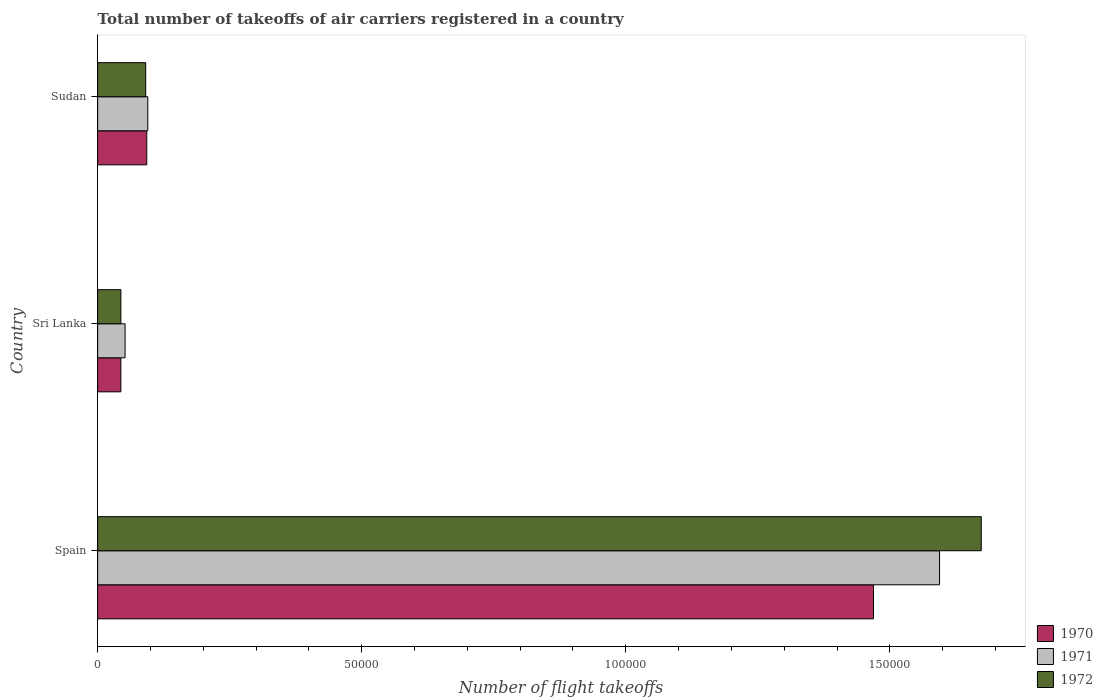How many different coloured bars are there?
Your answer should be very brief. 3. Are the number of bars on each tick of the Y-axis equal?
Give a very brief answer. Yes. How many bars are there on the 1st tick from the top?
Provide a succinct answer. 3. How many bars are there on the 1st tick from the bottom?
Keep it short and to the point. 3. What is the label of the 2nd group of bars from the top?
Offer a terse response. Sri Lanka. What is the total number of flight takeoffs in 1972 in Sudan?
Provide a short and direct response. 9100. Across all countries, what is the maximum total number of flight takeoffs in 1972?
Your response must be concise. 1.67e+05. Across all countries, what is the minimum total number of flight takeoffs in 1972?
Offer a terse response. 4400. In which country was the total number of flight takeoffs in 1971 maximum?
Your answer should be compact. Spain. In which country was the total number of flight takeoffs in 1971 minimum?
Ensure brevity in your answer.  Sri Lanka. What is the total total number of flight takeoffs in 1970 in the graph?
Your answer should be compact. 1.61e+05. What is the difference between the total number of flight takeoffs in 1972 in Sri Lanka and that in Sudan?
Offer a very short reply. -4700. What is the difference between the total number of flight takeoffs in 1971 in Spain and the total number of flight takeoffs in 1972 in Sudan?
Give a very brief answer. 1.50e+05. What is the average total number of flight takeoffs in 1972 per country?
Your answer should be compact. 6.03e+04. What is the difference between the total number of flight takeoffs in 1970 and total number of flight takeoffs in 1972 in Spain?
Provide a short and direct response. -2.04e+04. What is the ratio of the total number of flight takeoffs in 1972 in Sri Lanka to that in Sudan?
Ensure brevity in your answer.  0.48. Is the difference between the total number of flight takeoffs in 1970 in Spain and Sri Lanka greater than the difference between the total number of flight takeoffs in 1972 in Spain and Sri Lanka?
Provide a short and direct response. No. What is the difference between the highest and the second highest total number of flight takeoffs in 1971?
Keep it short and to the point. 1.50e+05. What is the difference between the highest and the lowest total number of flight takeoffs in 1970?
Your answer should be compact. 1.42e+05. In how many countries, is the total number of flight takeoffs in 1972 greater than the average total number of flight takeoffs in 1972 taken over all countries?
Provide a short and direct response. 1. What does the 3rd bar from the bottom in Sri Lanka represents?
Keep it short and to the point. 1972. Is it the case that in every country, the sum of the total number of flight takeoffs in 1971 and total number of flight takeoffs in 1970 is greater than the total number of flight takeoffs in 1972?
Offer a terse response. Yes. How many bars are there?
Offer a terse response. 9. Are all the bars in the graph horizontal?
Provide a succinct answer. Yes. How many countries are there in the graph?
Give a very brief answer. 3. What is the difference between two consecutive major ticks on the X-axis?
Your response must be concise. 5.00e+04. Are the values on the major ticks of X-axis written in scientific E-notation?
Your response must be concise. No. Does the graph contain grids?
Make the answer very short. No. Where does the legend appear in the graph?
Provide a succinct answer. Bottom right. What is the title of the graph?
Offer a terse response. Total number of takeoffs of air carriers registered in a country. Does "1967" appear as one of the legend labels in the graph?
Provide a succinct answer. No. What is the label or title of the X-axis?
Offer a terse response. Number of flight takeoffs. What is the Number of flight takeoffs of 1970 in Spain?
Provide a short and direct response. 1.47e+05. What is the Number of flight takeoffs in 1971 in Spain?
Your answer should be compact. 1.59e+05. What is the Number of flight takeoffs in 1972 in Spain?
Ensure brevity in your answer.  1.67e+05. What is the Number of flight takeoffs of 1970 in Sri Lanka?
Keep it short and to the point. 4400. What is the Number of flight takeoffs of 1971 in Sri Lanka?
Your answer should be compact. 5200. What is the Number of flight takeoffs in 1972 in Sri Lanka?
Keep it short and to the point. 4400. What is the Number of flight takeoffs in 1970 in Sudan?
Offer a very short reply. 9300. What is the Number of flight takeoffs of 1971 in Sudan?
Provide a short and direct response. 9500. What is the Number of flight takeoffs in 1972 in Sudan?
Offer a terse response. 9100. Across all countries, what is the maximum Number of flight takeoffs of 1970?
Provide a succinct answer. 1.47e+05. Across all countries, what is the maximum Number of flight takeoffs of 1971?
Keep it short and to the point. 1.59e+05. Across all countries, what is the maximum Number of flight takeoffs of 1972?
Offer a terse response. 1.67e+05. Across all countries, what is the minimum Number of flight takeoffs in 1970?
Offer a very short reply. 4400. Across all countries, what is the minimum Number of flight takeoffs of 1971?
Provide a succinct answer. 5200. Across all countries, what is the minimum Number of flight takeoffs in 1972?
Your answer should be very brief. 4400. What is the total Number of flight takeoffs in 1970 in the graph?
Provide a succinct answer. 1.61e+05. What is the total Number of flight takeoffs in 1971 in the graph?
Your response must be concise. 1.74e+05. What is the total Number of flight takeoffs of 1972 in the graph?
Provide a short and direct response. 1.81e+05. What is the difference between the Number of flight takeoffs of 1970 in Spain and that in Sri Lanka?
Keep it short and to the point. 1.42e+05. What is the difference between the Number of flight takeoffs in 1971 in Spain and that in Sri Lanka?
Ensure brevity in your answer.  1.54e+05. What is the difference between the Number of flight takeoffs of 1972 in Spain and that in Sri Lanka?
Ensure brevity in your answer.  1.63e+05. What is the difference between the Number of flight takeoffs in 1970 in Spain and that in Sudan?
Keep it short and to the point. 1.38e+05. What is the difference between the Number of flight takeoffs of 1971 in Spain and that in Sudan?
Your response must be concise. 1.50e+05. What is the difference between the Number of flight takeoffs of 1972 in Spain and that in Sudan?
Your response must be concise. 1.58e+05. What is the difference between the Number of flight takeoffs in 1970 in Sri Lanka and that in Sudan?
Ensure brevity in your answer.  -4900. What is the difference between the Number of flight takeoffs of 1971 in Sri Lanka and that in Sudan?
Provide a succinct answer. -4300. What is the difference between the Number of flight takeoffs in 1972 in Sri Lanka and that in Sudan?
Keep it short and to the point. -4700. What is the difference between the Number of flight takeoffs of 1970 in Spain and the Number of flight takeoffs of 1971 in Sri Lanka?
Your answer should be very brief. 1.42e+05. What is the difference between the Number of flight takeoffs in 1970 in Spain and the Number of flight takeoffs in 1972 in Sri Lanka?
Make the answer very short. 1.42e+05. What is the difference between the Number of flight takeoffs in 1971 in Spain and the Number of flight takeoffs in 1972 in Sri Lanka?
Your answer should be compact. 1.55e+05. What is the difference between the Number of flight takeoffs of 1970 in Spain and the Number of flight takeoffs of 1971 in Sudan?
Give a very brief answer. 1.37e+05. What is the difference between the Number of flight takeoffs of 1970 in Spain and the Number of flight takeoffs of 1972 in Sudan?
Make the answer very short. 1.38e+05. What is the difference between the Number of flight takeoffs in 1971 in Spain and the Number of flight takeoffs in 1972 in Sudan?
Offer a terse response. 1.50e+05. What is the difference between the Number of flight takeoffs of 1970 in Sri Lanka and the Number of flight takeoffs of 1971 in Sudan?
Provide a succinct answer. -5100. What is the difference between the Number of flight takeoffs of 1970 in Sri Lanka and the Number of flight takeoffs of 1972 in Sudan?
Provide a succinct answer. -4700. What is the difference between the Number of flight takeoffs in 1971 in Sri Lanka and the Number of flight takeoffs in 1972 in Sudan?
Give a very brief answer. -3900. What is the average Number of flight takeoffs of 1970 per country?
Your answer should be compact. 5.35e+04. What is the average Number of flight takeoffs in 1971 per country?
Provide a short and direct response. 5.80e+04. What is the average Number of flight takeoffs of 1972 per country?
Keep it short and to the point. 6.03e+04. What is the difference between the Number of flight takeoffs of 1970 and Number of flight takeoffs of 1971 in Spain?
Provide a short and direct response. -1.25e+04. What is the difference between the Number of flight takeoffs in 1970 and Number of flight takeoffs in 1972 in Spain?
Give a very brief answer. -2.04e+04. What is the difference between the Number of flight takeoffs in 1971 and Number of flight takeoffs in 1972 in Spain?
Your answer should be compact. -7900. What is the difference between the Number of flight takeoffs in 1970 and Number of flight takeoffs in 1971 in Sri Lanka?
Keep it short and to the point. -800. What is the difference between the Number of flight takeoffs of 1971 and Number of flight takeoffs of 1972 in Sri Lanka?
Ensure brevity in your answer.  800. What is the difference between the Number of flight takeoffs in 1970 and Number of flight takeoffs in 1971 in Sudan?
Your response must be concise. -200. What is the ratio of the Number of flight takeoffs of 1970 in Spain to that in Sri Lanka?
Offer a very short reply. 33.39. What is the ratio of the Number of flight takeoffs in 1971 in Spain to that in Sri Lanka?
Ensure brevity in your answer.  30.65. What is the ratio of the Number of flight takeoffs in 1972 in Spain to that in Sri Lanka?
Offer a very short reply. 38.02. What is the ratio of the Number of flight takeoffs of 1970 in Spain to that in Sudan?
Give a very brief answer. 15.8. What is the ratio of the Number of flight takeoffs of 1971 in Spain to that in Sudan?
Keep it short and to the point. 16.78. What is the ratio of the Number of flight takeoffs in 1972 in Spain to that in Sudan?
Your answer should be very brief. 18.38. What is the ratio of the Number of flight takeoffs of 1970 in Sri Lanka to that in Sudan?
Your answer should be compact. 0.47. What is the ratio of the Number of flight takeoffs of 1971 in Sri Lanka to that in Sudan?
Offer a very short reply. 0.55. What is the ratio of the Number of flight takeoffs in 1972 in Sri Lanka to that in Sudan?
Offer a terse response. 0.48. What is the difference between the highest and the second highest Number of flight takeoffs in 1970?
Provide a short and direct response. 1.38e+05. What is the difference between the highest and the second highest Number of flight takeoffs in 1971?
Make the answer very short. 1.50e+05. What is the difference between the highest and the second highest Number of flight takeoffs in 1972?
Provide a succinct answer. 1.58e+05. What is the difference between the highest and the lowest Number of flight takeoffs of 1970?
Give a very brief answer. 1.42e+05. What is the difference between the highest and the lowest Number of flight takeoffs in 1971?
Provide a succinct answer. 1.54e+05. What is the difference between the highest and the lowest Number of flight takeoffs of 1972?
Provide a short and direct response. 1.63e+05. 